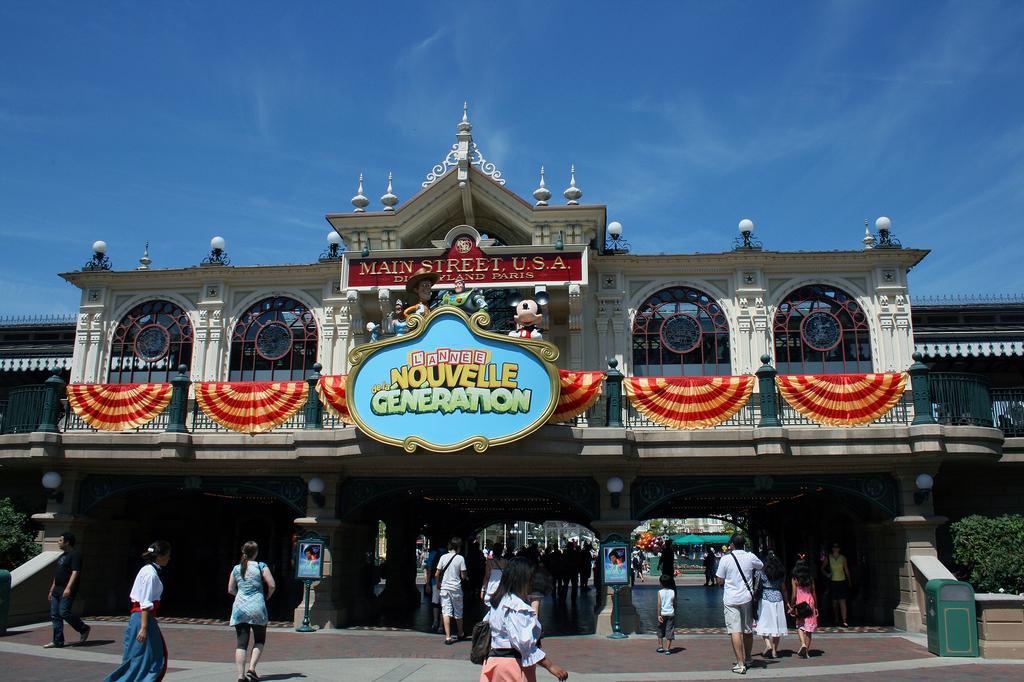Please provide a concise description of this image. At the bottom there are group of people walking on the road and in the platform area. In the middle there is a building on which board is there and windows are visible and curtains are there. On the top there is a sky of blue in color. On both side, left and bottom planets are visible and a fence visible on the middle. This image is taken on the road during day time. 